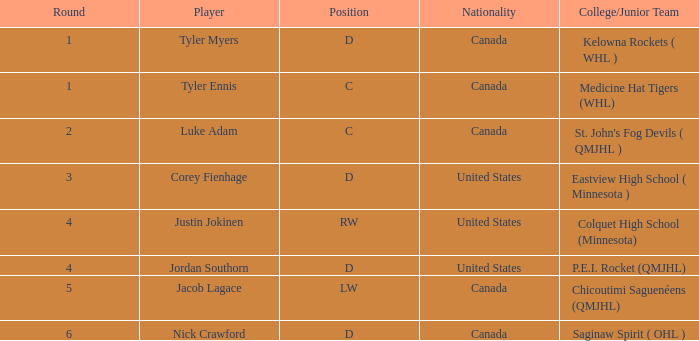What is the college/junior team of player tyler myers, who has a pick less than 44? Kelowna Rockets ( WHL ). 